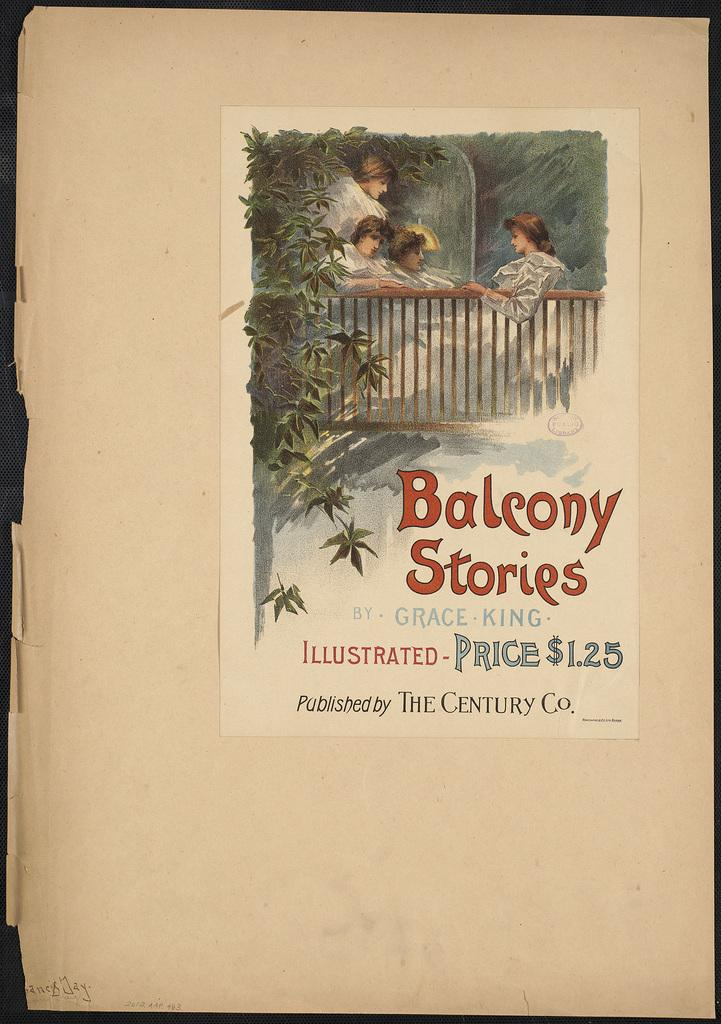<image>
Describe the image concisely. A book cover that reads Balcony Stories by Grace King. 